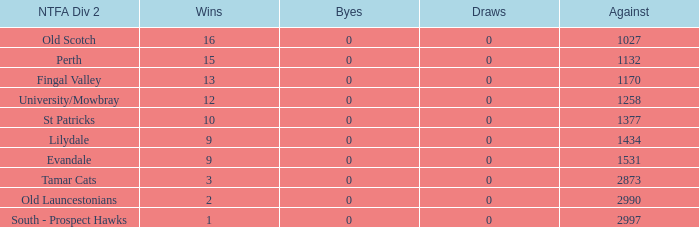What is the lowest number of draws of the NTFA Div 2 Lilydale? 0.0. Could you parse the entire table? {'header': ['NTFA Div 2', 'Wins', 'Byes', 'Draws', 'Against'], 'rows': [['Old Scotch', '16', '0', '0', '1027'], ['Perth', '15', '0', '0', '1132'], ['Fingal Valley', '13', '0', '0', '1170'], ['University/Mowbray', '12', '0', '0', '1258'], ['St Patricks', '10', '0', '0', '1377'], ['Lilydale', '9', '0', '0', '1434'], ['Evandale', '9', '0', '0', '1531'], ['Tamar Cats', '3', '0', '0', '2873'], ['Old Launcestonians', '2', '0', '0', '2990'], ['South - Prospect Hawks', '1', '0', '0', '2997']]} 